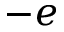Convert formula to latex. <formula><loc_0><loc_0><loc_500><loc_500>- e</formula> 